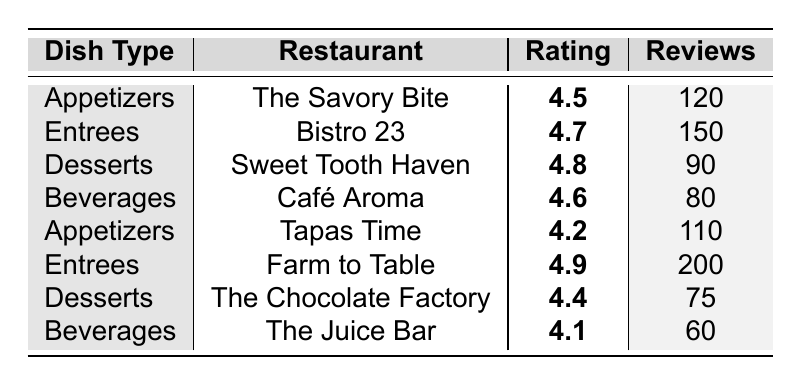What is the highest-rated dish type? The highest rating in the table is 4.9, which belongs to the Entrees served at Farm to Table.
Answer: Entrees Which restaurant has the most reviews for its entrees? Looking specifically at the Entrees category, Farm to Table has 200 reviews, which is the highest count compared to Bistro 23, which has 150 reviews.
Answer: Farm to Table What is the average rating for appetizers? The ratings for appetizers are 4.5 from The Savory Bite and 4.2 from Tapas Time. Calculating the average: (4.5 + 4.2) / 2 = 4.35.
Answer: 4.35 What is the rating difference between the best and worst dish type? The highest rating is 4.9 (Entrees) and the lowest rating is 4.1 (Beverages). The difference is: 4.9 - 4.1 = 0.8.
Answer: 0.8 Which dessert has a higher rating, Sweet Tooth Haven or The Chocolate Factory? Sweet Tooth Haven has a rating of 4.8, while The Chocolate Factory has a rating of 4.4. Since 4.8 is greater than 4.4, Sweet Tooth Haven is higher rated.
Answer: Sweet Tooth Haven Is there any dish type with a rating above 4.6? The table shows two ratings above 4.6: Entrees (4.9) and Desserts (4.8). Therefore, the answer is yes.
Answer: Yes How many total reviews are there for desserts across all restaurants? The review counts for desserts are 90 from Sweet Tooth Haven and 75 from The Chocolate Factory. Summing these gives a total of: 90 + 75 = 165.
Answer: 165 Which dish type has the lowest number of reviews? The table shows Beverages with the lowest review count of 60, compared to the other dish types.
Answer: Beverages Which restaurant has the highest rating of all the dishes listed? The restaurant with the highest rating is Farm to Table with a rating of 4.9 for Entrees.
Answer: Farm to Table What is the total number of reviews for appetizers? The total reviews for appetizers include 120 from The Savory Bite and 110 from Tapas Time. Adding these gives: 120 + 110 = 230.
Answer: 230 